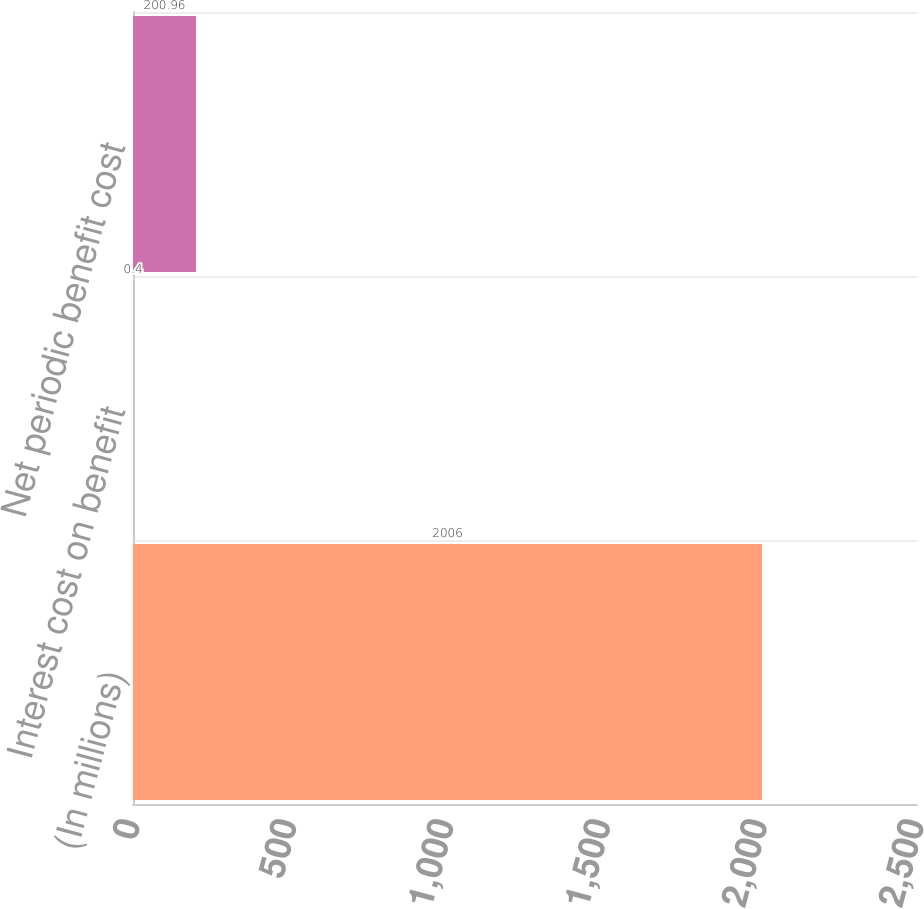<chart> <loc_0><loc_0><loc_500><loc_500><bar_chart><fcel>(In millions)<fcel>Interest cost on benefit<fcel>Net periodic benefit cost<nl><fcel>2006<fcel>0.4<fcel>200.96<nl></chart> 